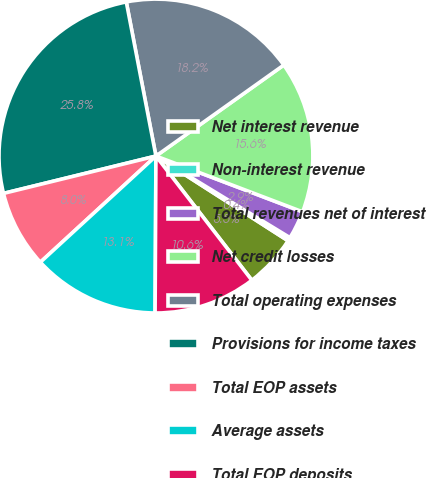<chart> <loc_0><loc_0><loc_500><loc_500><pie_chart><fcel>Net interest revenue<fcel>Non-interest revenue<fcel>Total revenues net of interest<fcel>Net credit losses<fcel>Total operating expenses<fcel>Provisions for income taxes<fcel>Total EOP assets<fcel>Average assets<fcel>Total EOP deposits<nl><fcel>5.46%<fcel>0.37%<fcel>2.92%<fcel>15.63%<fcel>18.18%<fcel>25.8%<fcel>8.0%<fcel>13.09%<fcel>10.55%<nl></chart> 